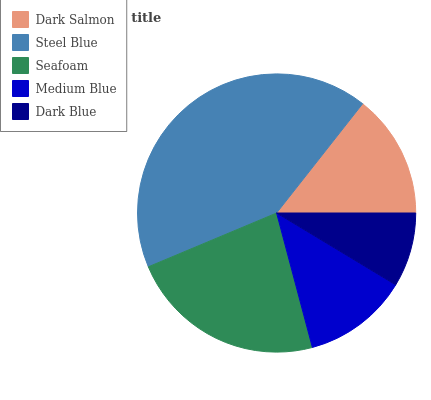Is Dark Blue the minimum?
Answer yes or no. Yes. Is Steel Blue the maximum?
Answer yes or no. Yes. Is Seafoam the minimum?
Answer yes or no. No. Is Seafoam the maximum?
Answer yes or no. No. Is Steel Blue greater than Seafoam?
Answer yes or no. Yes. Is Seafoam less than Steel Blue?
Answer yes or no. Yes. Is Seafoam greater than Steel Blue?
Answer yes or no. No. Is Steel Blue less than Seafoam?
Answer yes or no. No. Is Dark Salmon the high median?
Answer yes or no. Yes. Is Dark Salmon the low median?
Answer yes or no. Yes. Is Dark Blue the high median?
Answer yes or no. No. Is Medium Blue the low median?
Answer yes or no. No. 